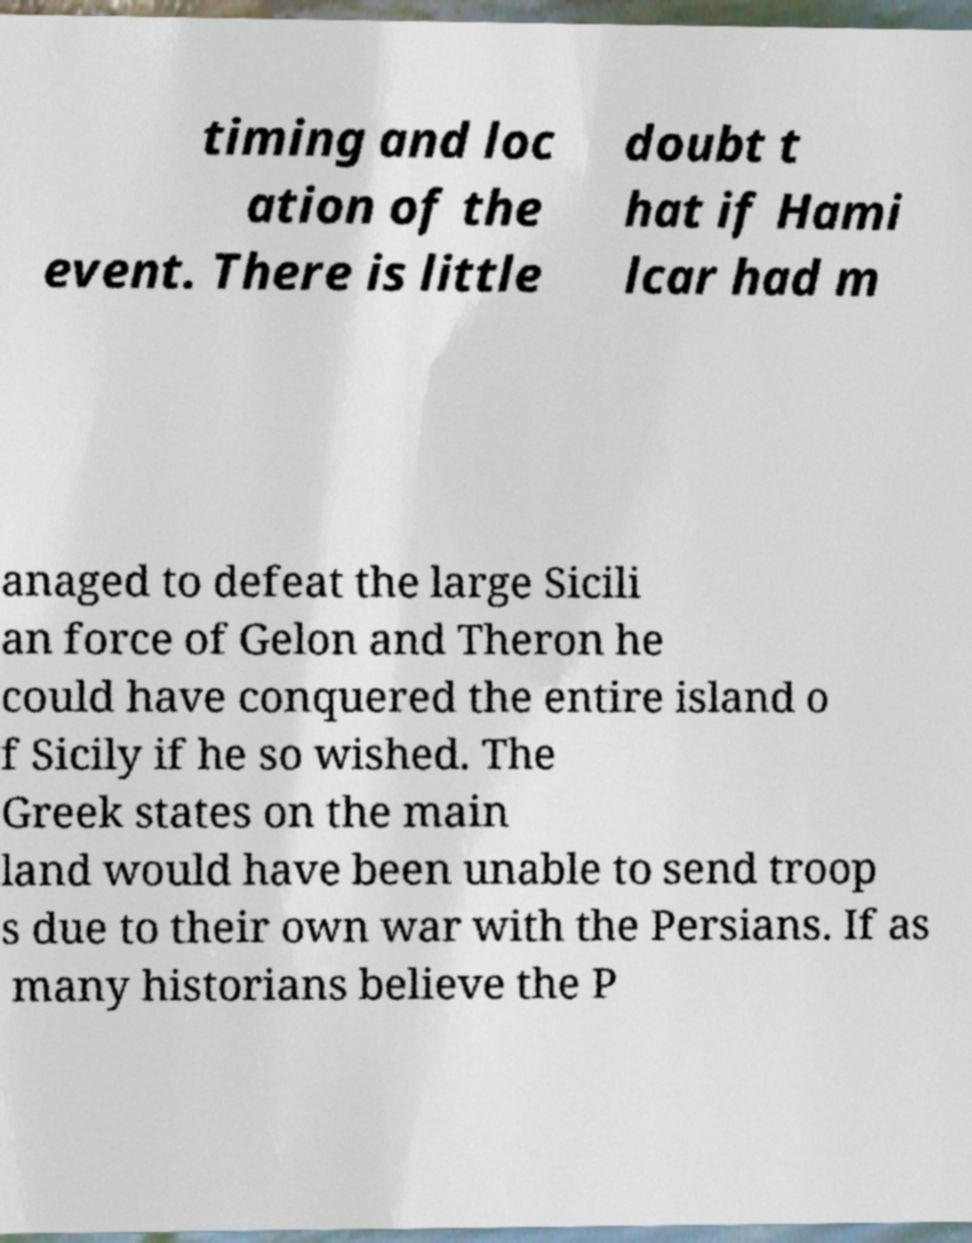What messages or text are displayed in this image? I need them in a readable, typed format. timing and loc ation of the event. There is little doubt t hat if Hami lcar had m anaged to defeat the large Sicili an force of Gelon and Theron he could have conquered the entire island o f Sicily if he so wished. The Greek states on the main land would have been unable to send troop s due to their own war with the Persians. If as many historians believe the P 